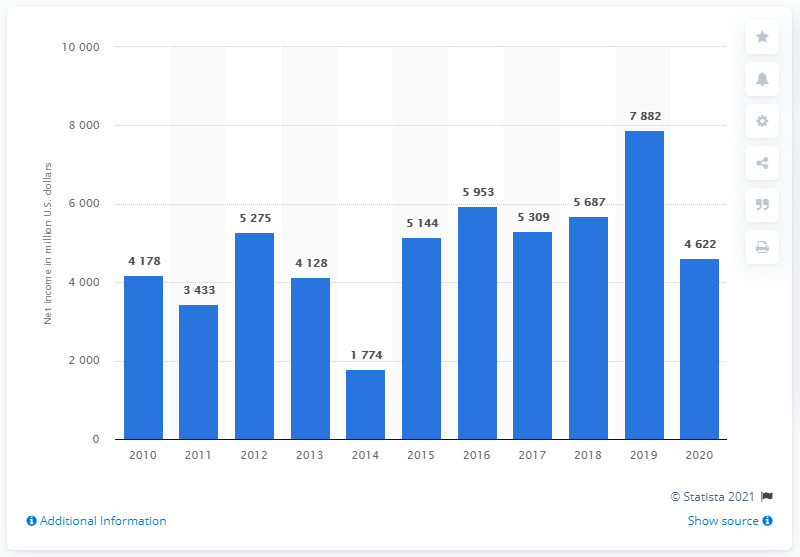Draw attention to some important aspects in this diagram. AbbVie's net earnings in 2020 were 4,622. 